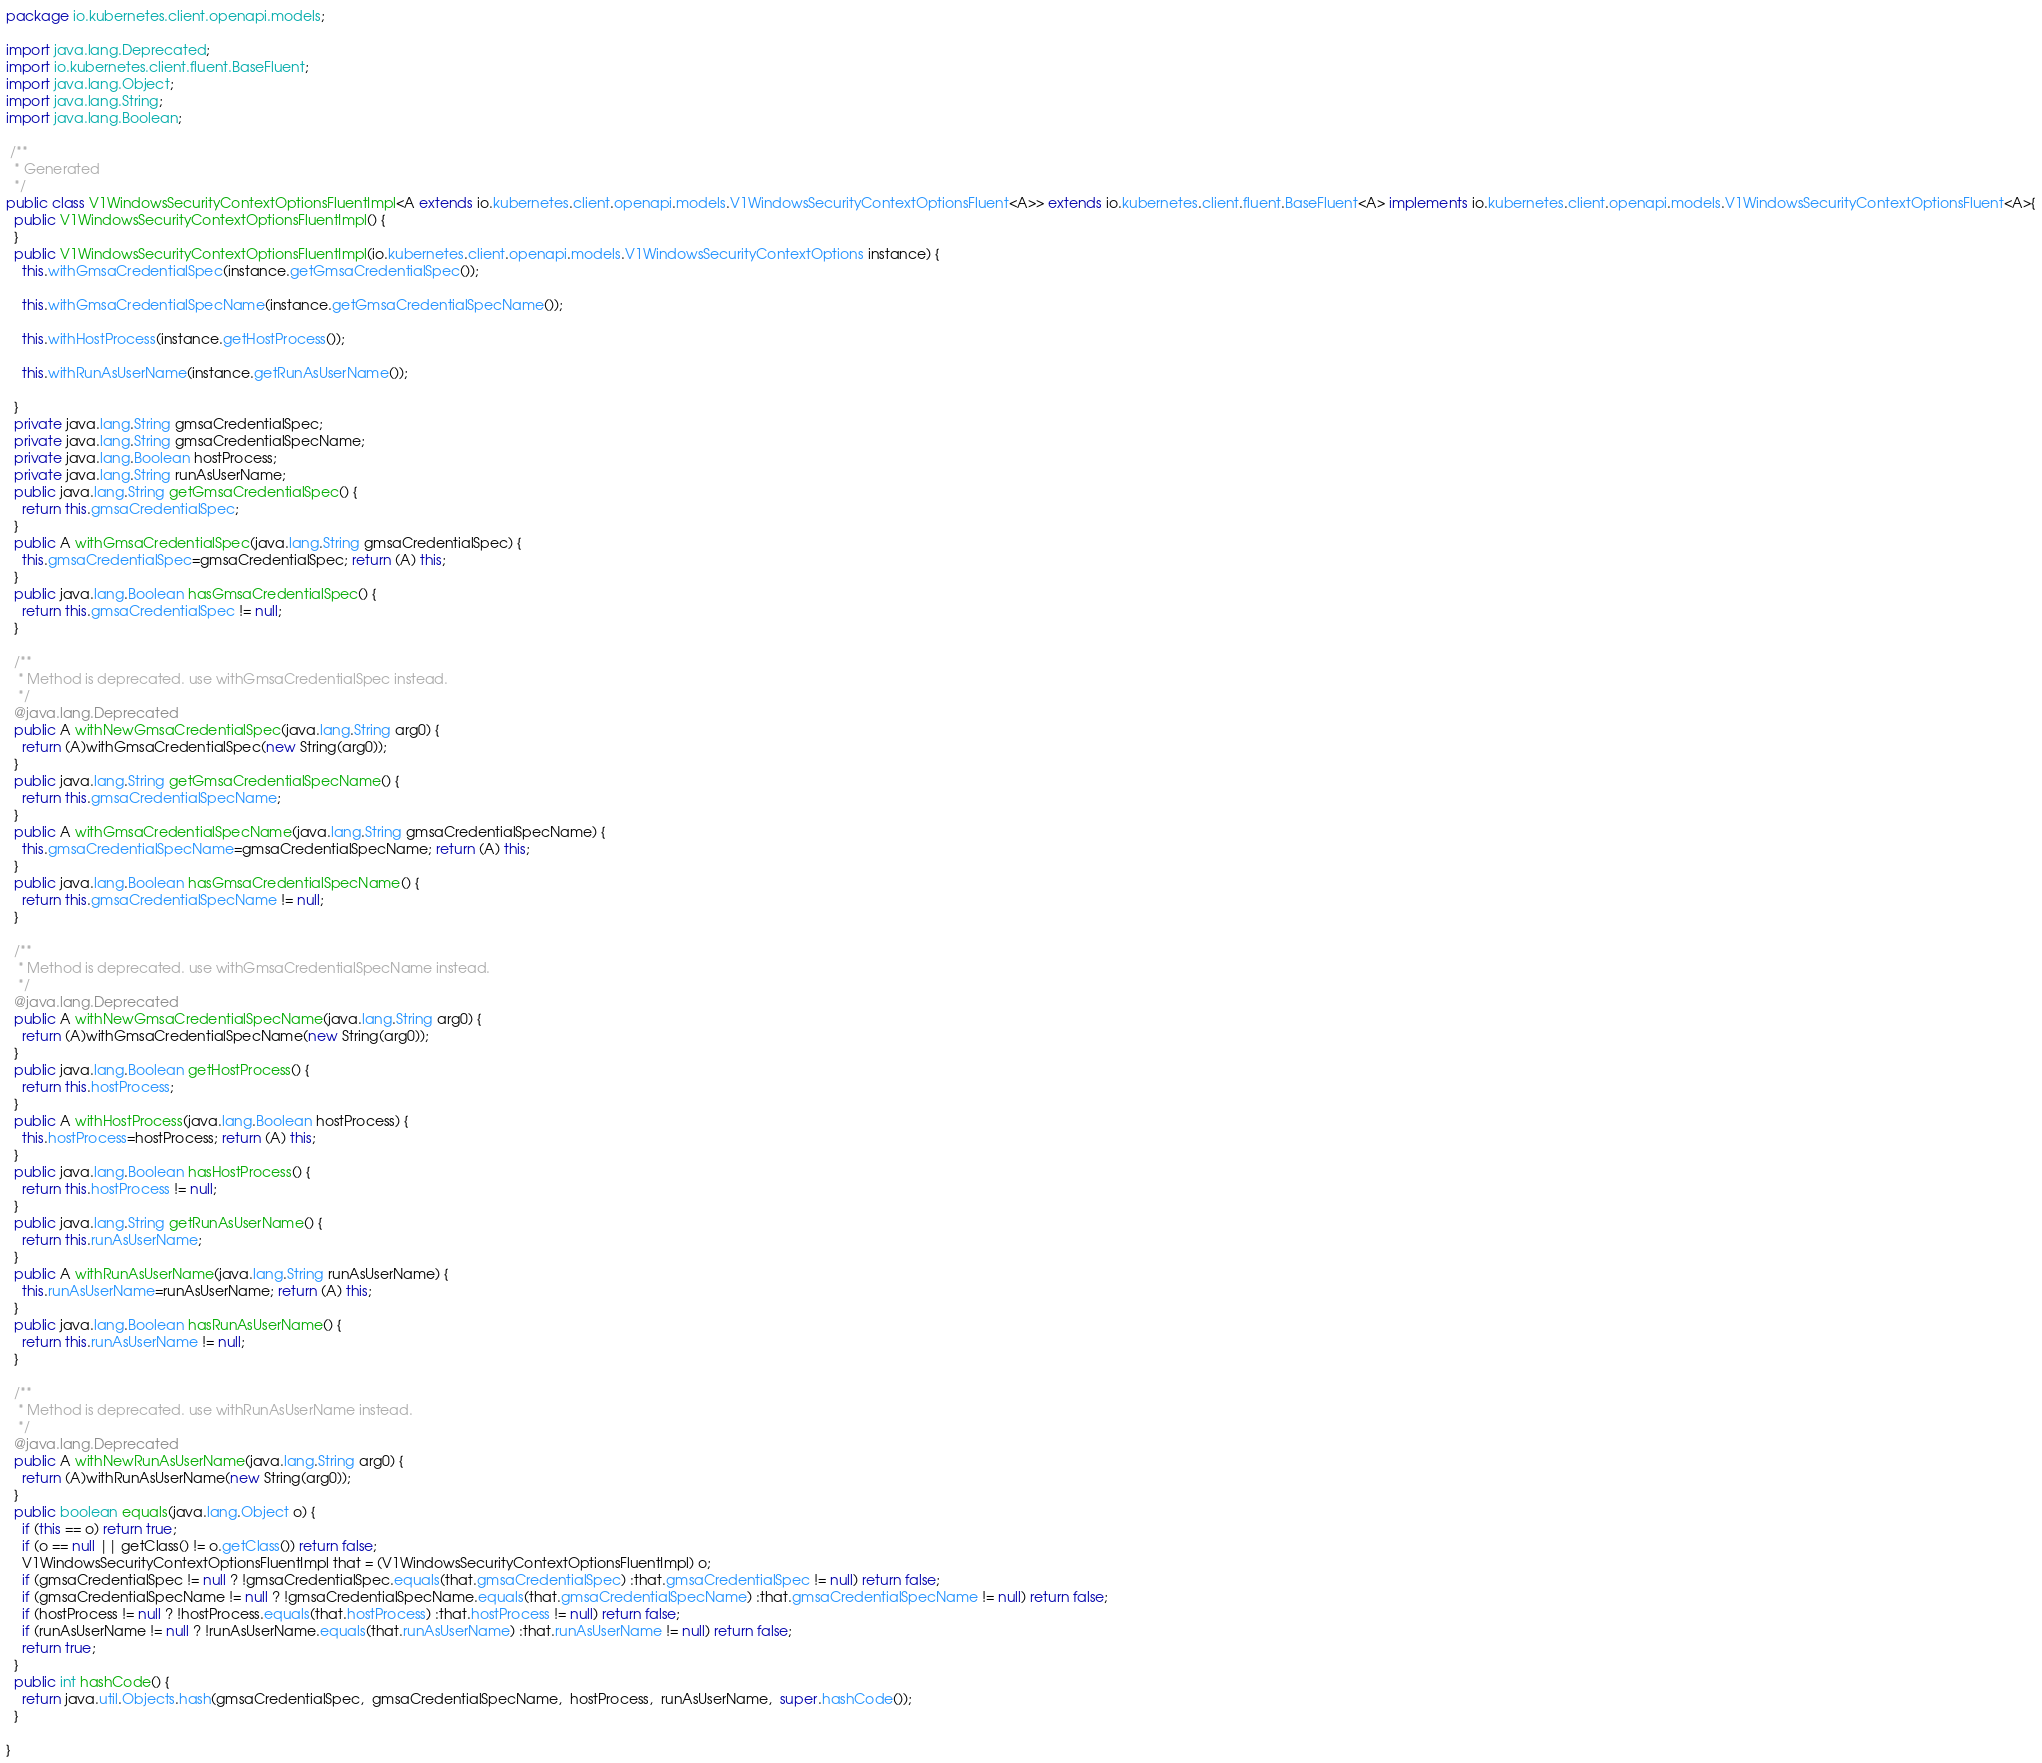Convert code to text. <code><loc_0><loc_0><loc_500><loc_500><_Java_>package io.kubernetes.client.openapi.models;

import java.lang.Deprecated;
import io.kubernetes.client.fluent.BaseFluent;
import java.lang.Object;
import java.lang.String;
import java.lang.Boolean;

 /**
  * Generated
  */
public class V1WindowsSecurityContextOptionsFluentImpl<A extends io.kubernetes.client.openapi.models.V1WindowsSecurityContextOptionsFluent<A>> extends io.kubernetes.client.fluent.BaseFluent<A> implements io.kubernetes.client.openapi.models.V1WindowsSecurityContextOptionsFluent<A>{
  public V1WindowsSecurityContextOptionsFluentImpl() {
  }
  public V1WindowsSecurityContextOptionsFluentImpl(io.kubernetes.client.openapi.models.V1WindowsSecurityContextOptions instance) {
    this.withGmsaCredentialSpec(instance.getGmsaCredentialSpec());

    this.withGmsaCredentialSpecName(instance.getGmsaCredentialSpecName());

    this.withHostProcess(instance.getHostProcess());

    this.withRunAsUserName(instance.getRunAsUserName());

  }
  private java.lang.String gmsaCredentialSpec;
  private java.lang.String gmsaCredentialSpecName;
  private java.lang.Boolean hostProcess;
  private java.lang.String runAsUserName;
  public java.lang.String getGmsaCredentialSpec() {
    return this.gmsaCredentialSpec;
  }
  public A withGmsaCredentialSpec(java.lang.String gmsaCredentialSpec) {
    this.gmsaCredentialSpec=gmsaCredentialSpec; return (A) this;
  }
  public java.lang.Boolean hasGmsaCredentialSpec() {
    return this.gmsaCredentialSpec != null;
  }
  
  /**
   * Method is deprecated. use withGmsaCredentialSpec instead.
   */
  @java.lang.Deprecated
  public A withNewGmsaCredentialSpec(java.lang.String arg0) {
    return (A)withGmsaCredentialSpec(new String(arg0));
  }
  public java.lang.String getGmsaCredentialSpecName() {
    return this.gmsaCredentialSpecName;
  }
  public A withGmsaCredentialSpecName(java.lang.String gmsaCredentialSpecName) {
    this.gmsaCredentialSpecName=gmsaCredentialSpecName; return (A) this;
  }
  public java.lang.Boolean hasGmsaCredentialSpecName() {
    return this.gmsaCredentialSpecName != null;
  }
  
  /**
   * Method is deprecated. use withGmsaCredentialSpecName instead.
   */
  @java.lang.Deprecated
  public A withNewGmsaCredentialSpecName(java.lang.String arg0) {
    return (A)withGmsaCredentialSpecName(new String(arg0));
  }
  public java.lang.Boolean getHostProcess() {
    return this.hostProcess;
  }
  public A withHostProcess(java.lang.Boolean hostProcess) {
    this.hostProcess=hostProcess; return (A) this;
  }
  public java.lang.Boolean hasHostProcess() {
    return this.hostProcess != null;
  }
  public java.lang.String getRunAsUserName() {
    return this.runAsUserName;
  }
  public A withRunAsUserName(java.lang.String runAsUserName) {
    this.runAsUserName=runAsUserName; return (A) this;
  }
  public java.lang.Boolean hasRunAsUserName() {
    return this.runAsUserName != null;
  }
  
  /**
   * Method is deprecated. use withRunAsUserName instead.
   */
  @java.lang.Deprecated
  public A withNewRunAsUserName(java.lang.String arg0) {
    return (A)withRunAsUserName(new String(arg0));
  }
  public boolean equals(java.lang.Object o) {
    if (this == o) return true;
    if (o == null || getClass() != o.getClass()) return false;
    V1WindowsSecurityContextOptionsFluentImpl that = (V1WindowsSecurityContextOptionsFluentImpl) o;
    if (gmsaCredentialSpec != null ? !gmsaCredentialSpec.equals(that.gmsaCredentialSpec) :that.gmsaCredentialSpec != null) return false;
    if (gmsaCredentialSpecName != null ? !gmsaCredentialSpecName.equals(that.gmsaCredentialSpecName) :that.gmsaCredentialSpecName != null) return false;
    if (hostProcess != null ? !hostProcess.equals(that.hostProcess) :that.hostProcess != null) return false;
    if (runAsUserName != null ? !runAsUserName.equals(that.runAsUserName) :that.runAsUserName != null) return false;
    return true;
  }
  public int hashCode() {
    return java.util.Objects.hash(gmsaCredentialSpec,  gmsaCredentialSpecName,  hostProcess,  runAsUserName,  super.hashCode());
  }
  
}</code> 